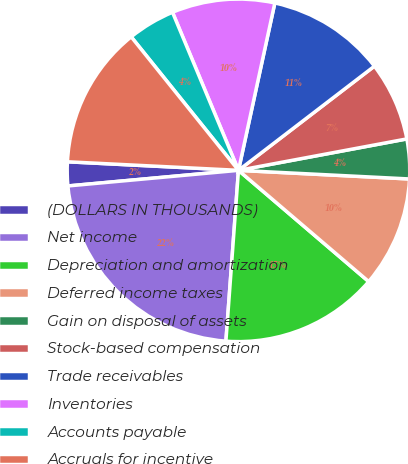Convert chart to OTSL. <chart><loc_0><loc_0><loc_500><loc_500><pie_chart><fcel>(DOLLARS IN THOUSANDS)<fcel>Net income<fcel>Depreciation and amortization<fcel>Deferred income taxes<fcel>Gain on disposal of assets<fcel>Stock-based compensation<fcel>Trade receivables<fcel>Inventories<fcel>Accounts payable<fcel>Accruals for incentive<nl><fcel>2.25%<fcel>22.38%<fcel>14.92%<fcel>10.45%<fcel>3.74%<fcel>7.47%<fcel>11.19%<fcel>9.7%<fcel>4.48%<fcel>13.43%<nl></chart> 